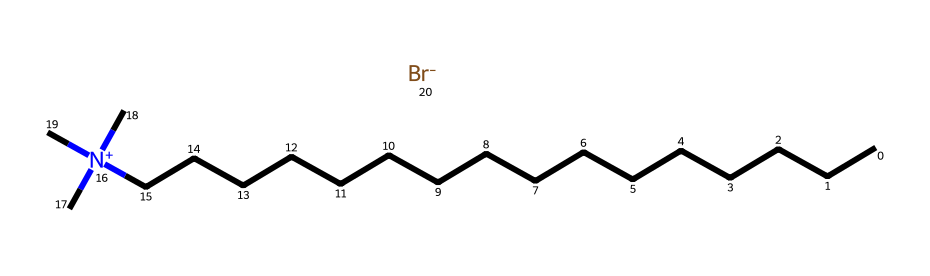What is the molecular formula of cetrimonium bromide (CTAB)? By analyzing the components in the SMILES representation, we can deduce the molecular formula: there are 16 carbon atoms (C), 34 hydrogen atoms (H), 1 nitrogen atom (N), and 1 bromine atom (Br). Thus, the combination results in the formula C16H34BrN.
Answer: C16H34BrN How many carbon atoms are present in the structure? The SMILES representation shows a long chain of "C" characters indicating carbon atoms. There are a total of 16 "C" characters present.
Answer: 16 What type of surfactant is cetrimonium bromide? The structure contains a positively charged nitrogen atom (indicated by [N+] in the SMILES), which is characteristic of cationic surfactants.
Answer: cationic What feature of this molecule contributes to its surfactant properties? The presence of a long hydrophobic alkyl chain (16 carbon atoms) combined with a hydrophilic quaternary ammonium group provides the amphiphilic nature that is critical for its surfactant properties.
Answer: hydrophobic alkyl chain What charge does the nitrogen atom have in cetrimonium bromide? The nitrogen atom is represented as [N+], which indicates that it carries a positive charge. Thus, this is a key feature of the molecule’s classification as a cationic surfactant.
Answer: positive How many hydrogen atoms are connected to the nitrogen atom in the structure? In the SMILES, the nitrogen atom is attached to three methyl groups (denoted by (C)(C)(C)) and has no hydrogen atoms directly attached, resulting in no hydrogen connections with the nitrogen atom.
Answer: 0 What role does the bromine atom play in cetrimonium bromide? The bromine atom (Br-) serves as the counterion to balance the positive charge of the quaternary nitrogen, stabilizing the molecule and enhancing its functionality as a surfactant.
Answer: counterion 